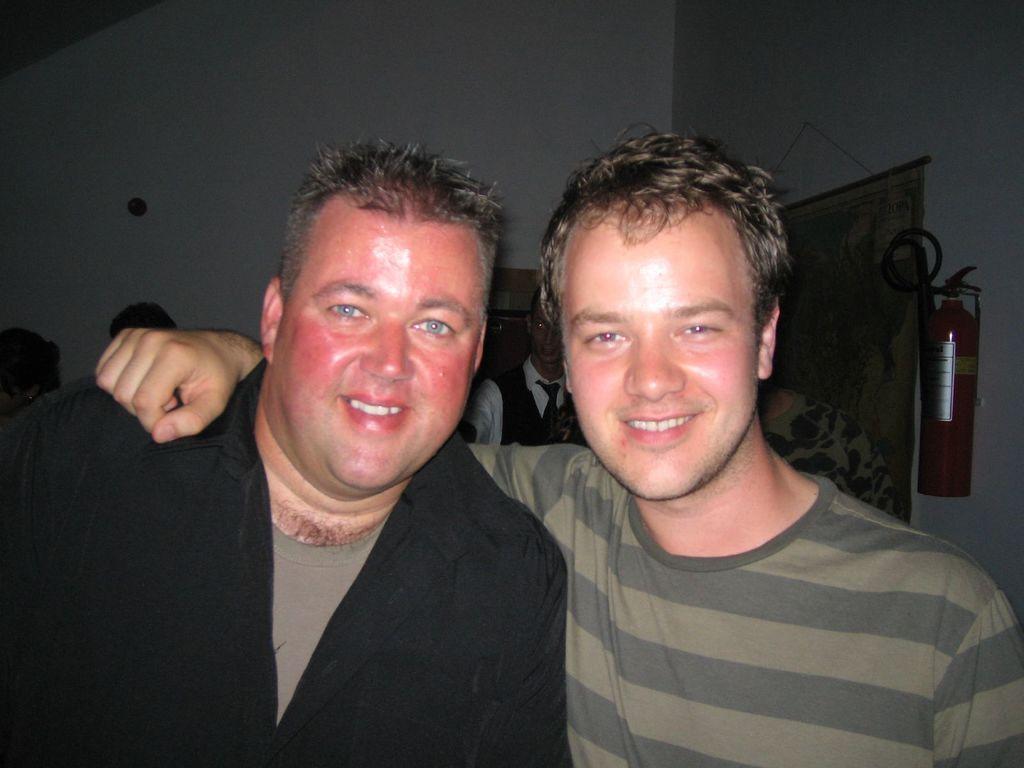Describe this image in one or two sentences. In this picture I can see two persons smiling, there are group of people, there is an oxygen cylinder, this is looking like a map hanging to the wall, and in the background there is a wall. 